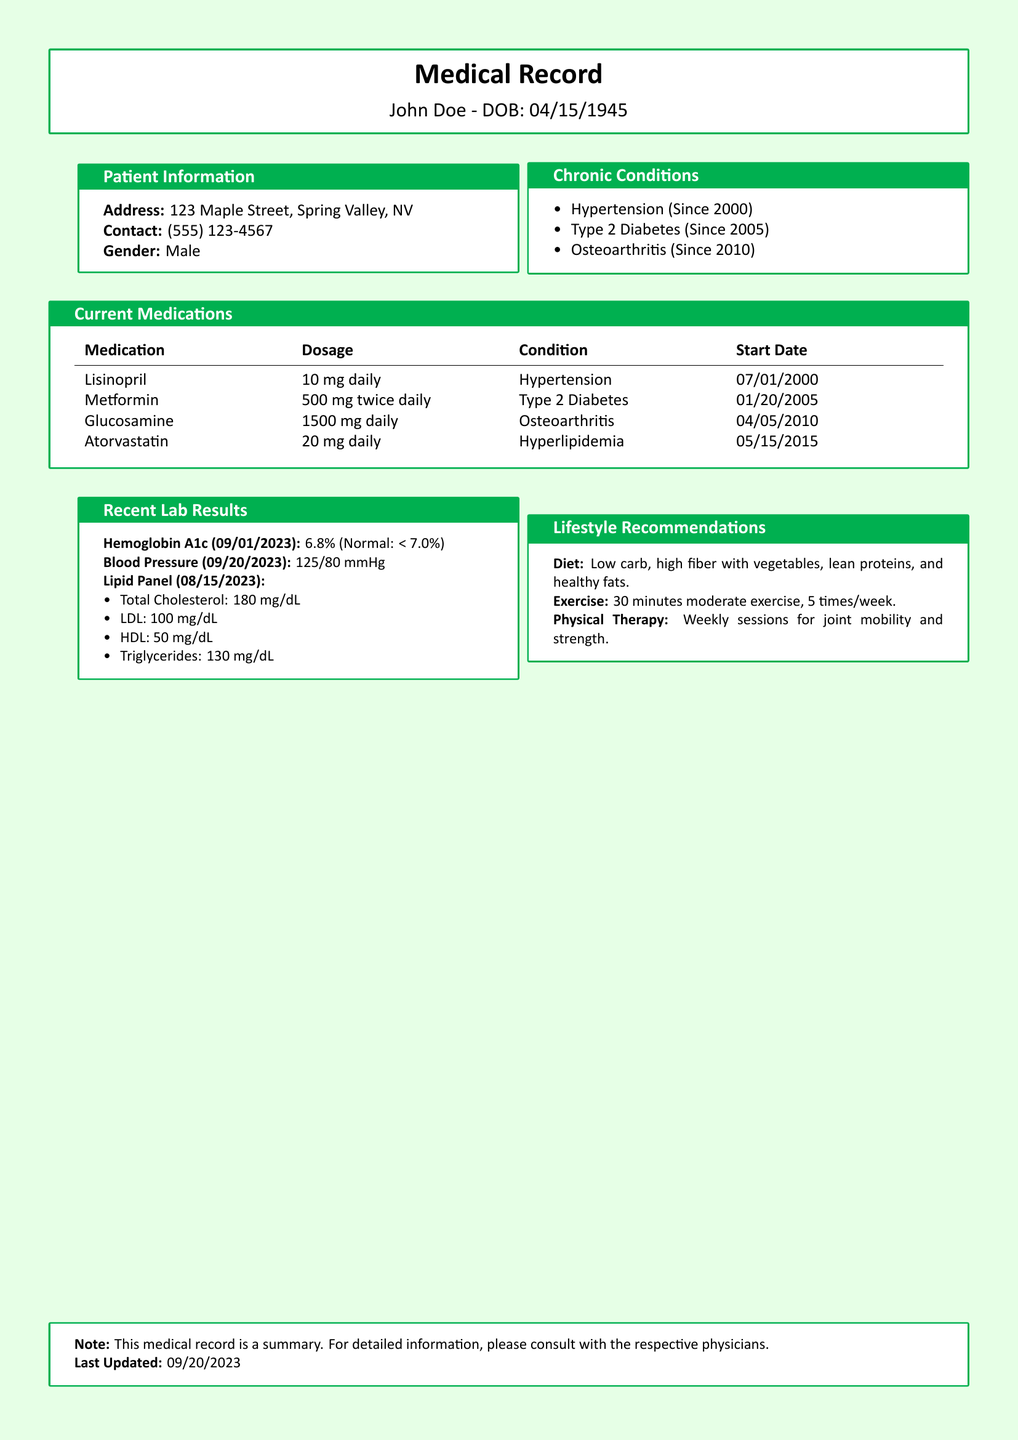What is the patient's date of birth? The patient's date of birth is indicated as 04/15/1945 in the document.
Answer: 04/15/1945 What conditions has the patient been diagnosed with? The document lists three chronic conditions the patient suffers from: Hypertension, Type 2 Diabetes, and Osteoarthritis.
Answer: Hypertension, Type 2 Diabetes, Osteoarthritis When did the patient start taking Metformin? The start date for Metformin is specified in the document as 01/20/2005.
Answer: 01/20/2005 What is the most recent Hemoglobin A1c level? The latest Hemoglobin A1c result is mentioned as 6.8% from the lab results.
Answer: 6.8% What lifestyle recommendation is provided for exercise? The document states that the exercise recommendation is 30 minutes of moderate exercise, 5 times a week.
Answer: 30 minutes moderate exercise, 5 times/week What is the dosage of Lisinopril? The medication dosage for Lisinopril is found in the current medications section as 10 mg daily.
Answer: 10 mg daily Which medication is prescribed for Hyperlipidemia? The document indicates that Atorvastatin is prescribed for Hyperlipidemia.
Answer: Atorvastatin What was the patient's blood pressure on 09/20/2023? The blood pressure reading is mentioned as 125/80 mmHg in the document.
Answer: 125/80 mmHg How long has the patient been prescribed Glucosamine? The prescription start date for Glucosamine is listed, which indicates that it has been prescribed since 04/05/2010.
Answer: Since 04/05/2010 